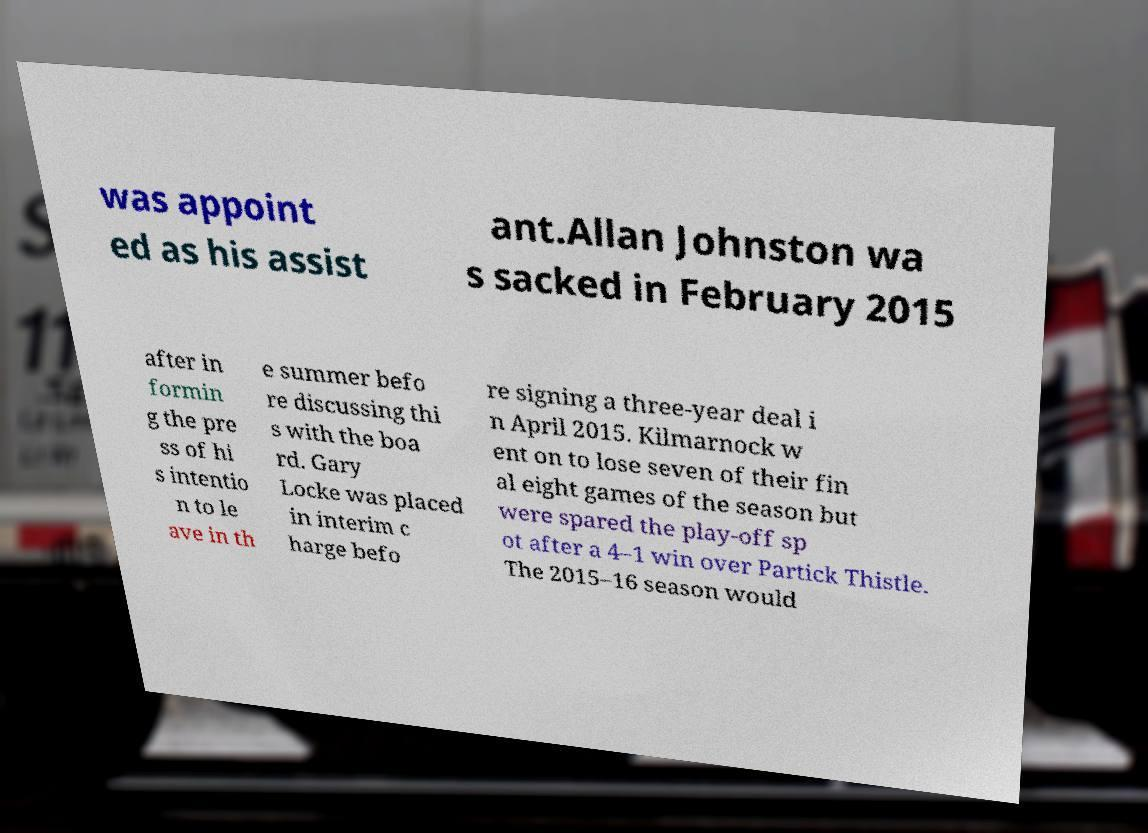I need the written content from this picture converted into text. Can you do that? was appoint ed as his assist ant.Allan Johnston wa s sacked in February 2015 after in formin g the pre ss of hi s intentio n to le ave in th e summer befo re discussing thi s with the boa rd. Gary Locke was placed in interim c harge befo re signing a three-year deal i n April 2015. Kilmarnock w ent on to lose seven of their fin al eight games of the season but were spared the play-off sp ot after a 4–1 win over Partick Thistle. The 2015–16 season would 